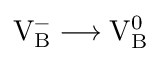<formula> <loc_0><loc_0><loc_500><loc_500>V _ { B } ^ { - } \longrightarrow V _ { B } ^ { 0 }</formula> 